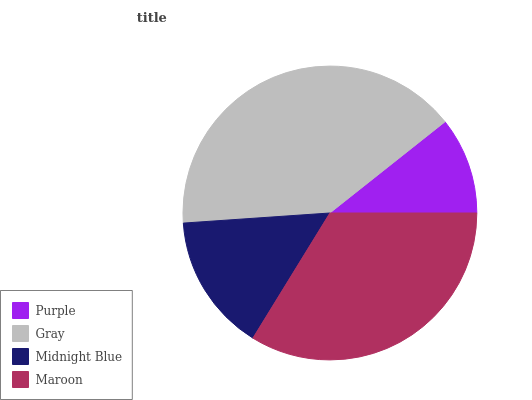Is Purple the minimum?
Answer yes or no. Yes. Is Gray the maximum?
Answer yes or no. Yes. Is Midnight Blue the minimum?
Answer yes or no. No. Is Midnight Blue the maximum?
Answer yes or no. No. Is Gray greater than Midnight Blue?
Answer yes or no. Yes. Is Midnight Blue less than Gray?
Answer yes or no. Yes. Is Midnight Blue greater than Gray?
Answer yes or no. No. Is Gray less than Midnight Blue?
Answer yes or no. No. Is Maroon the high median?
Answer yes or no. Yes. Is Midnight Blue the low median?
Answer yes or no. Yes. Is Midnight Blue the high median?
Answer yes or no. No. Is Gray the low median?
Answer yes or no. No. 